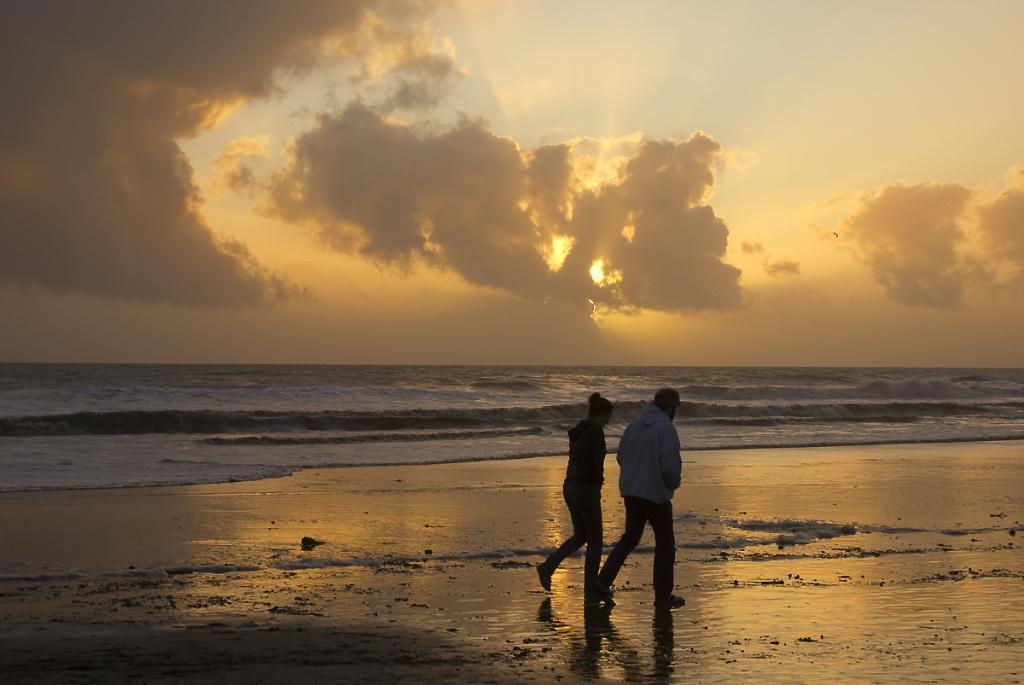What are the two people in the image doing? The two people in the image are walking. What can be seen in the image besides the people? There is water visible in the image. What is visible in the sky in the image? There are clouds in the sky. What part of the natural environment is visible in the image? The sky is visible in the background of the image. What type of mint is growing on the desk in the image? There is no mint or desk present in the image. Can you describe the bee's activity in the image? There are no bees present in the image. 